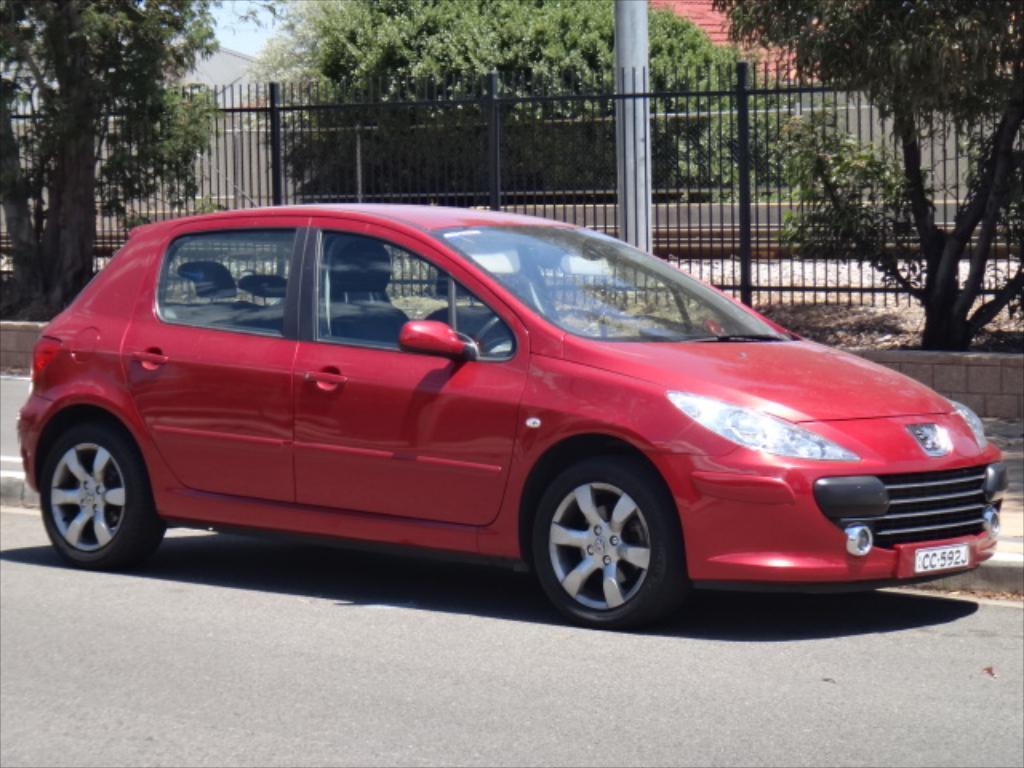What color is the car in the image? The car in the image is red. Where is the car located in the image? The car is on the road in the image. What can be seen in the background of the image? In the background of the image, there is a fence, trees, buildings, and the sky. What position does the wrist achiever hold in the image? There is no wrist achiever present in the image. The image features a red car on the road with a background that includes a fence, trees, buildings, and the sky. 